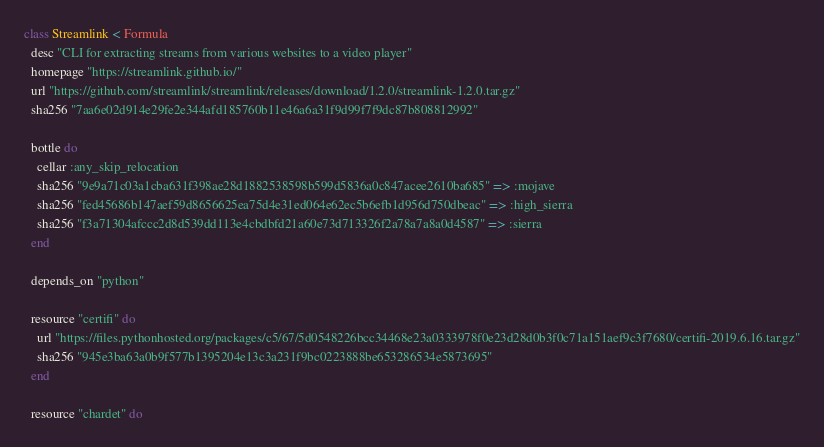<code> <loc_0><loc_0><loc_500><loc_500><_Ruby_>class Streamlink < Formula
  desc "CLI for extracting streams from various websites to a video player"
  homepage "https://streamlink.github.io/"
  url "https://github.com/streamlink/streamlink/releases/download/1.2.0/streamlink-1.2.0.tar.gz"
  sha256 "7aa6e02d914e29fe2e344afd185760b11e46a6a31f9d99f7f9dc87b808812992"

  bottle do
    cellar :any_skip_relocation
    sha256 "9e9a71c03a1cba631f398ae28d1882538598b599d5836a0c847acee2610ba685" => :mojave
    sha256 "fed45686b147aef59d8656625ea75d4e31ed064e62ec5b6efb1d956d750dbeac" => :high_sierra
    sha256 "f3a71304afccc2d8d539dd113e4cbdbfd21a60e73d713326f2a78a7a8a0d4587" => :sierra
  end

  depends_on "python"

  resource "certifi" do
    url "https://files.pythonhosted.org/packages/c5/67/5d0548226bcc34468e23a0333978f0e23d28d0b3f0c71a151aef9c3f7680/certifi-2019.6.16.tar.gz"
    sha256 "945e3ba63a0b9f577b1395204e13c3a231f9bc0223888be653286534e5873695"
  end

  resource "chardet" do</code> 